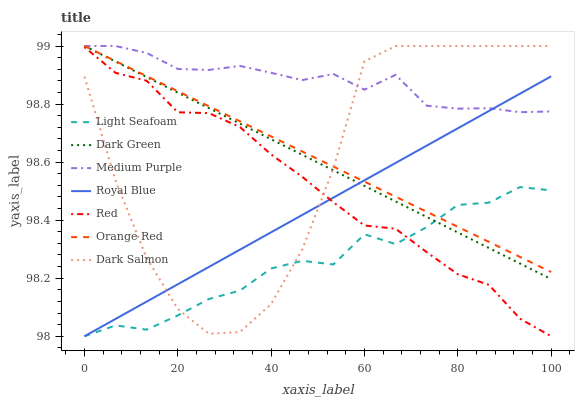Does Light Seafoam have the minimum area under the curve?
Answer yes or no. Yes. Does Medium Purple have the maximum area under the curve?
Answer yes or no. Yes. Does Royal Blue have the minimum area under the curve?
Answer yes or no. No. Does Royal Blue have the maximum area under the curve?
Answer yes or no. No. Is Orange Red the smoothest?
Answer yes or no. Yes. Is Dark Salmon the roughest?
Answer yes or no. Yes. Is Medium Purple the smoothest?
Answer yes or no. No. Is Medium Purple the roughest?
Answer yes or no. No. Does Royal Blue have the lowest value?
Answer yes or no. Yes. Does Medium Purple have the lowest value?
Answer yes or no. No. Does Dark Green have the highest value?
Answer yes or no. Yes. Does Royal Blue have the highest value?
Answer yes or no. No. Is Red less than Orange Red?
Answer yes or no. Yes. Is Medium Purple greater than Red?
Answer yes or no. Yes. Does Dark Green intersect Light Seafoam?
Answer yes or no. Yes. Is Dark Green less than Light Seafoam?
Answer yes or no. No. Is Dark Green greater than Light Seafoam?
Answer yes or no. No. Does Red intersect Orange Red?
Answer yes or no. No. 